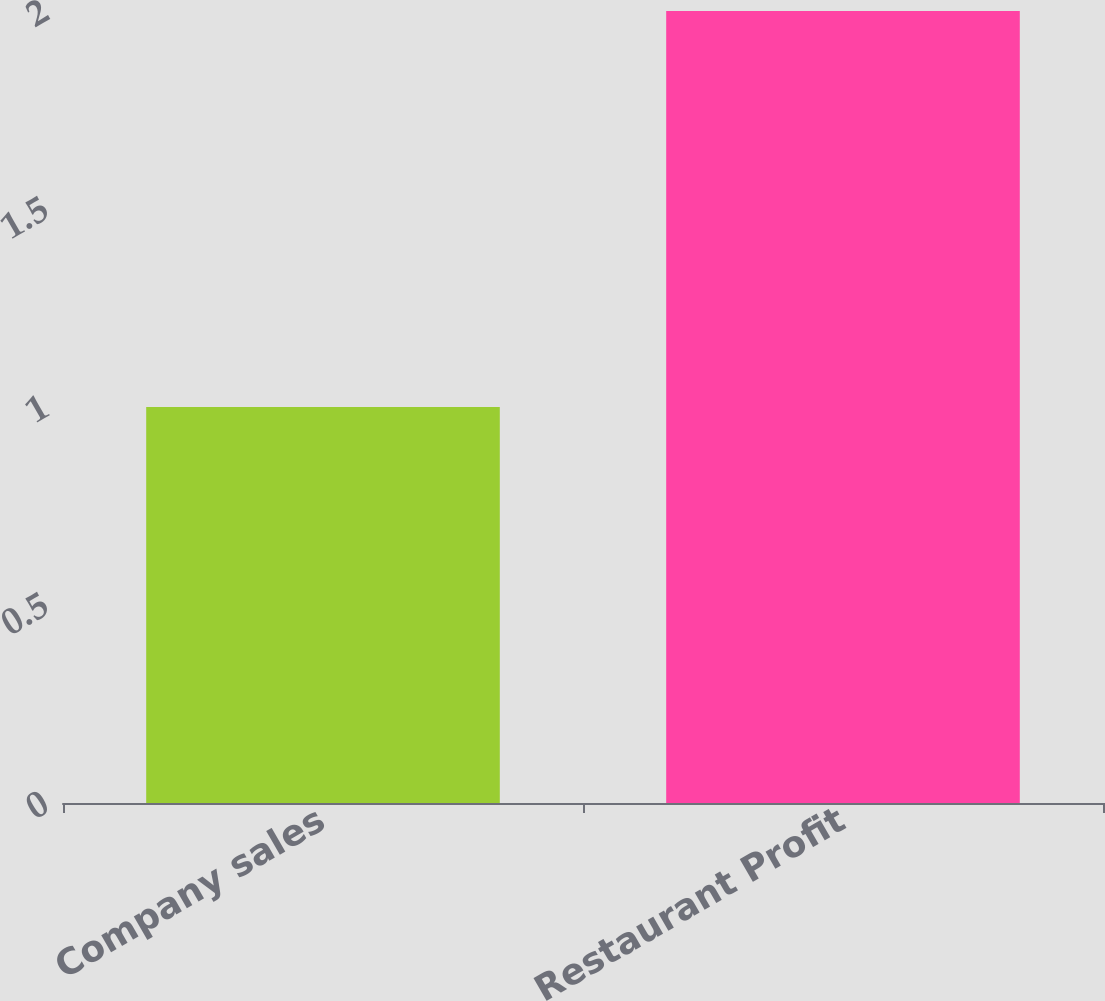Convert chart to OTSL. <chart><loc_0><loc_0><loc_500><loc_500><bar_chart><fcel>Company sales<fcel>Restaurant Profit<nl><fcel>1<fcel>2<nl></chart> 